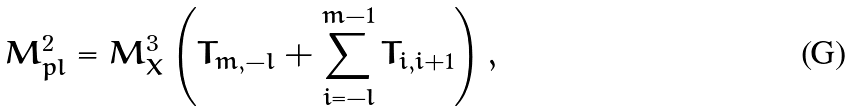<formula> <loc_0><loc_0><loc_500><loc_500>M _ { p l } ^ { 2 } = M _ { X } ^ { 3 } \left ( T _ { m , - l } + \sum _ { i = - l } ^ { m - 1 } T _ { i , i + 1 } \right ) , \,</formula> 